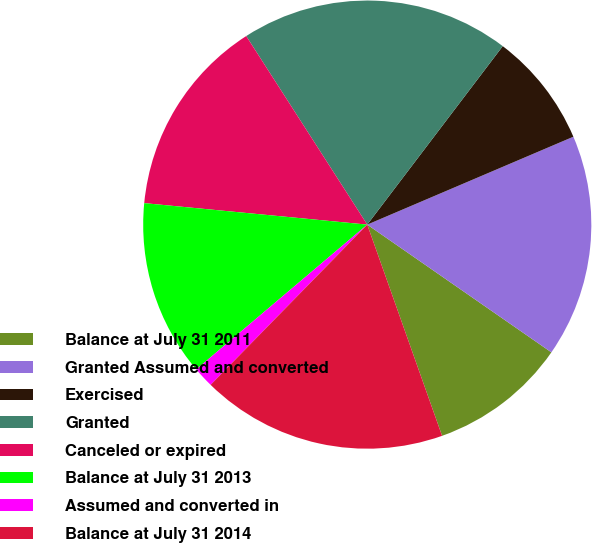Convert chart. <chart><loc_0><loc_0><loc_500><loc_500><pie_chart><fcel>Balance at July 31 2011<fcel>Granted Assumed and converted<fcel>Exercised<fcel>Granted<fcel>Canceled or expired<fcel>Balance at July 31 2013<fcel>Assumed and converted in<fcel>Balance at July 31 2014<nl><fcel>9.93%<fcel>16.07%<fcel>8.25%<fcel>19.42%<fcel>14.39%<fcel>12.71%<fcel>1.5%<fcel>17.74%<nl></chart> 